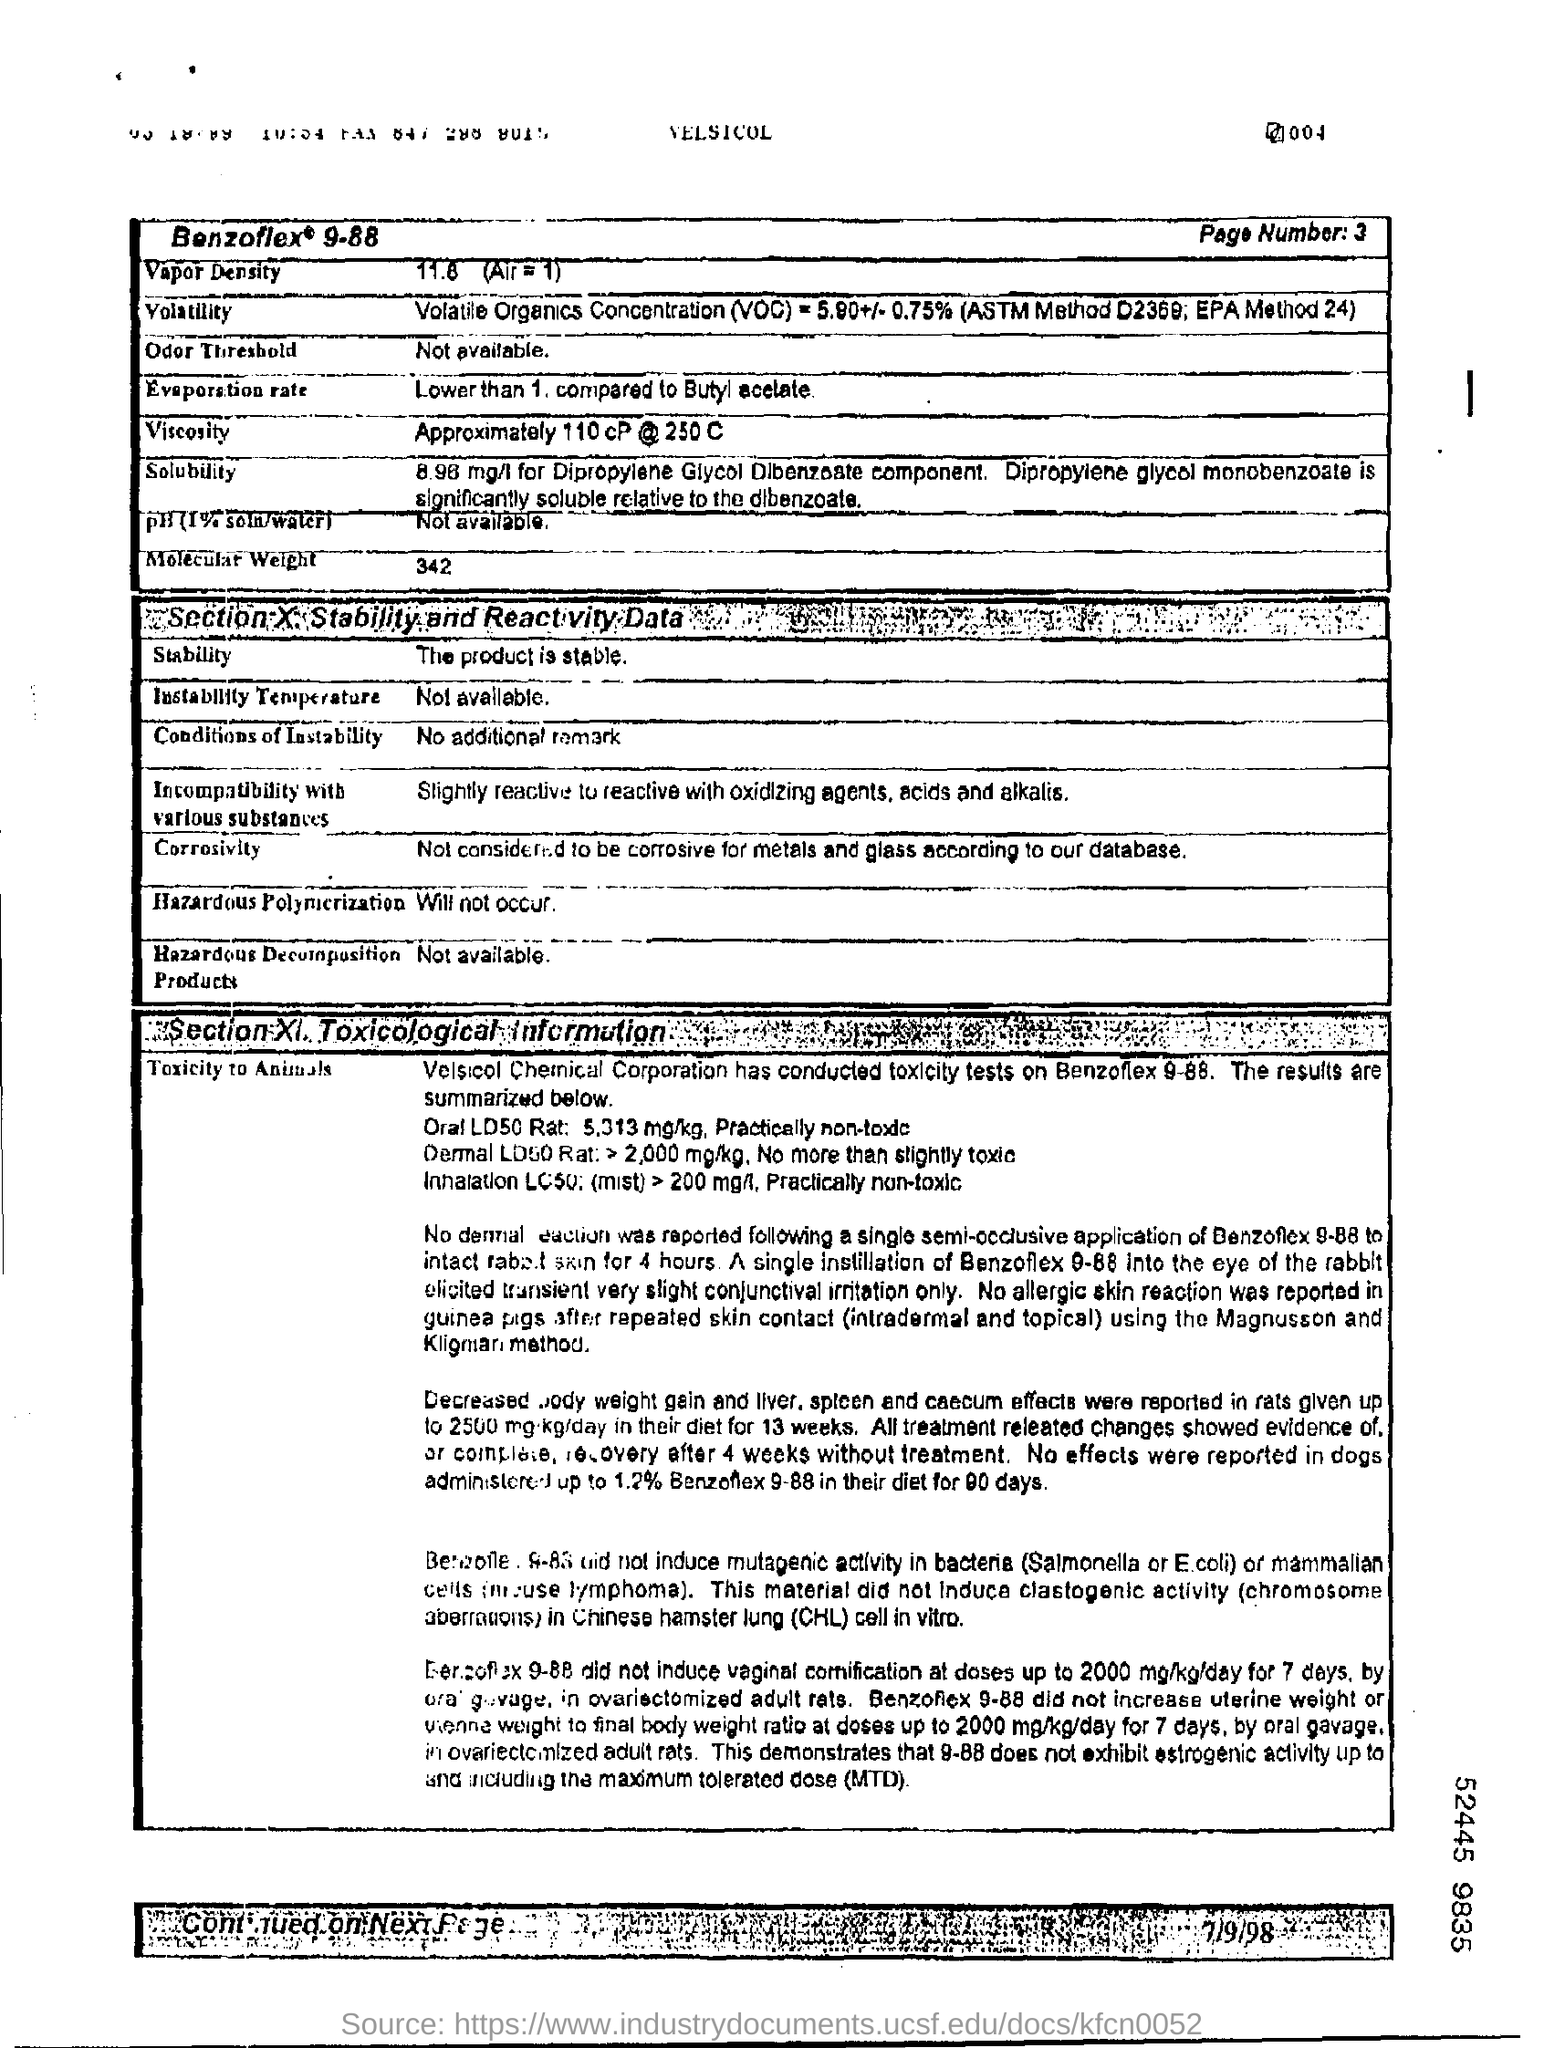Mention a couple of crucial points in this snapshot. The molecular weight of a substance is 342.. The vapor density is 11.8.. Hazardous polymerization will not occur. 